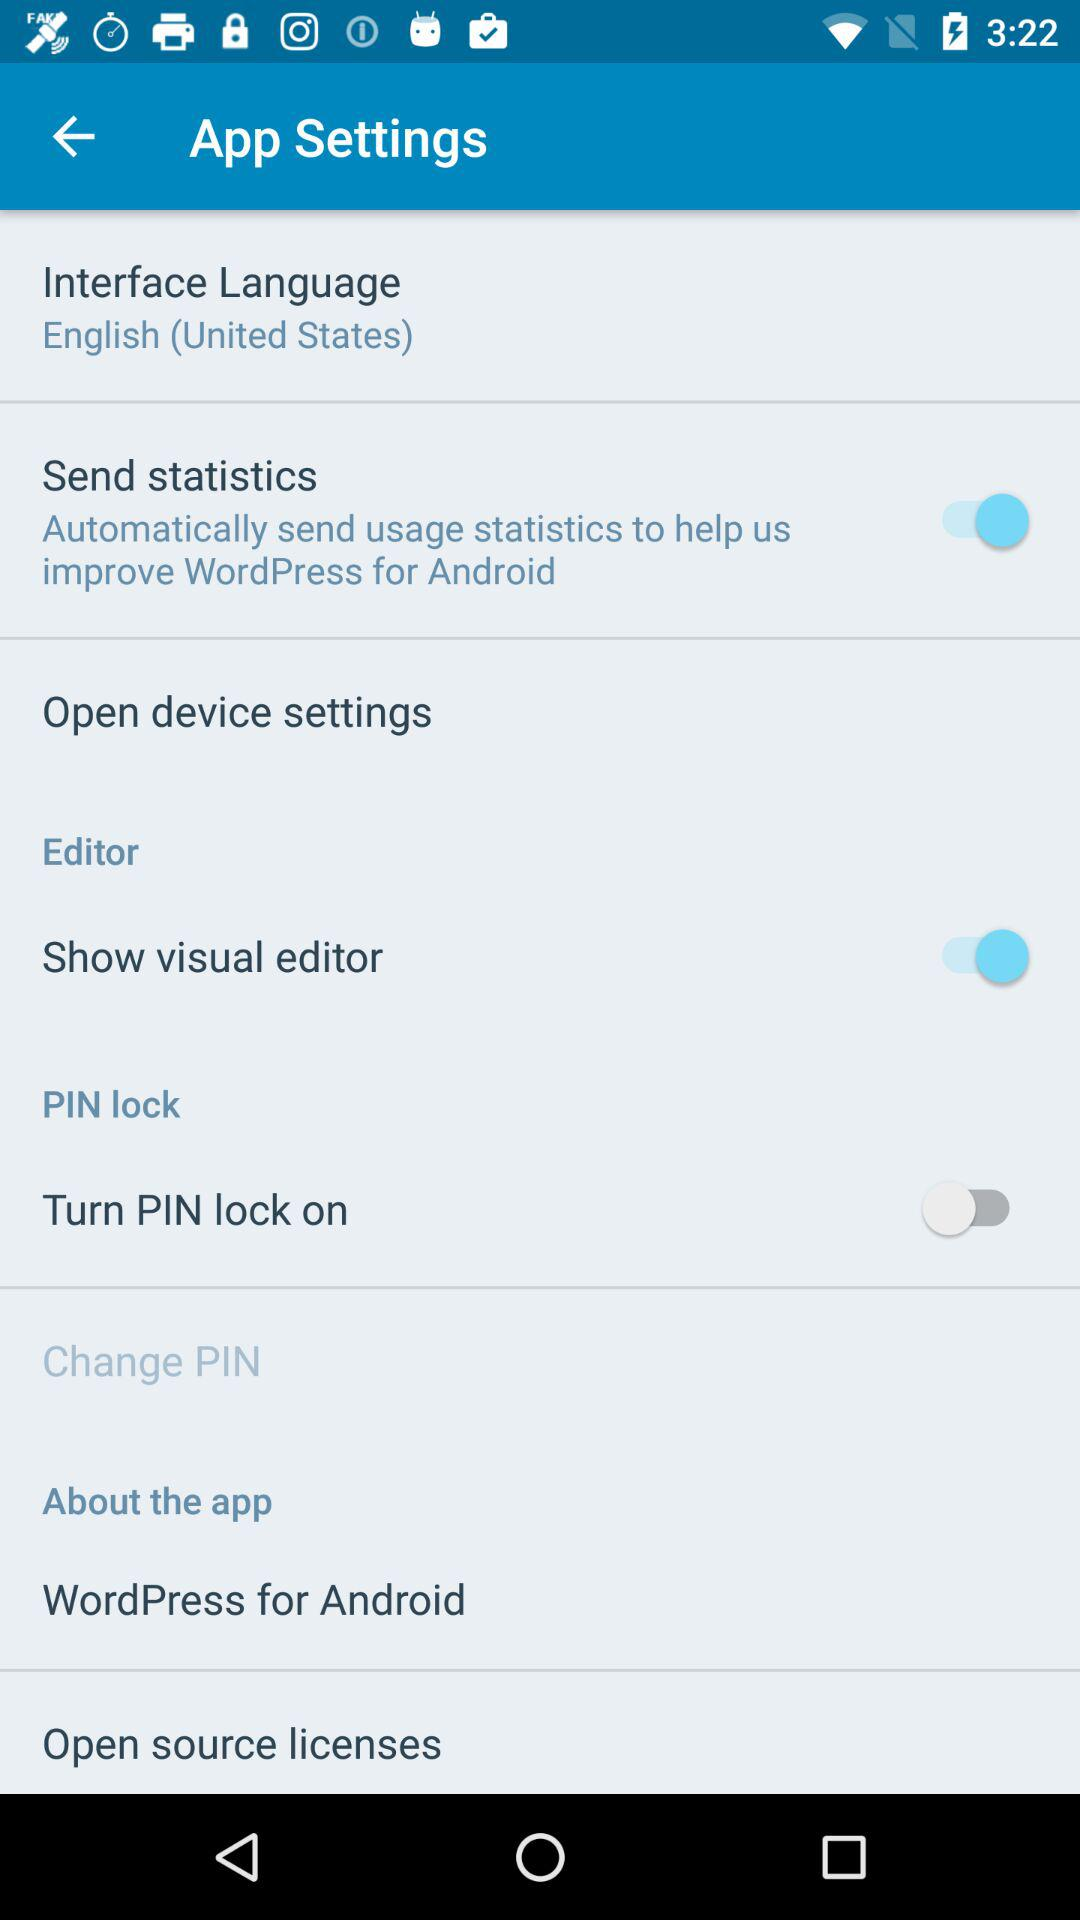How many options are there to control the PIN lock?
Answer the question using a single word or phrase. 2 